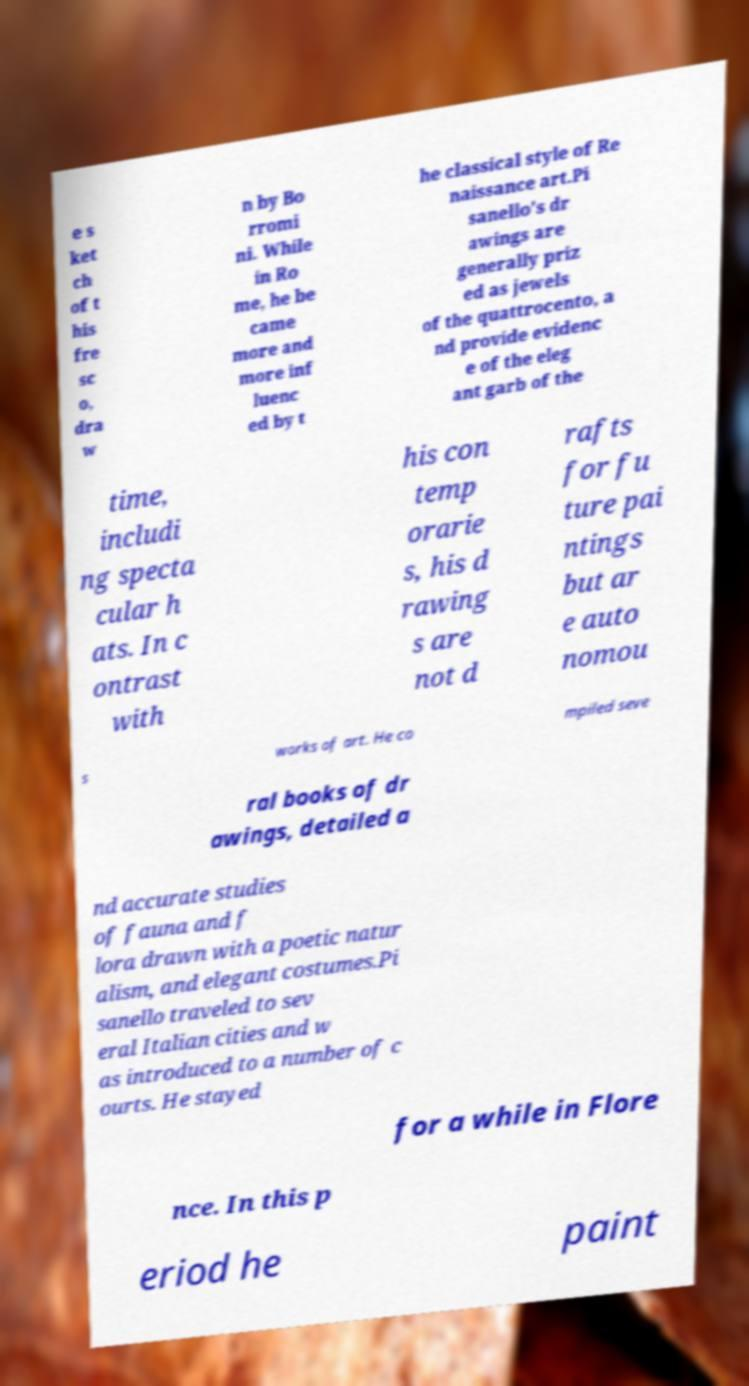Could you assist in decoding the text presented in this image and type it out clearly? e s ket ch of t his fre sc o, dra w n by Bo rromi ni. While in Ro me, he be came more and more inf luenc ed by t he classical style of Re naissance art.Pi sanello's dr awings are generally priz ed as jewels of the quattrocento, a nd provide evidenc e of the eleg ant garb of the time, includi ng specta cular h ats. In c ontrast with his con temp orarie s, his d rawing s are not d rafts for fu ture pai ntings but ar e auto nomou s works of art. He co mpiled seve ral books of dr awings, detailed a nd accurate studies of fauna and f lora drawn with a poetic natur alism, and elegant costumes.Pi sanello traveled to sev eral Italian cities and w as introduced to a number of c ourts. He stayed for a while in Flore nce. In this p eriod he paint 